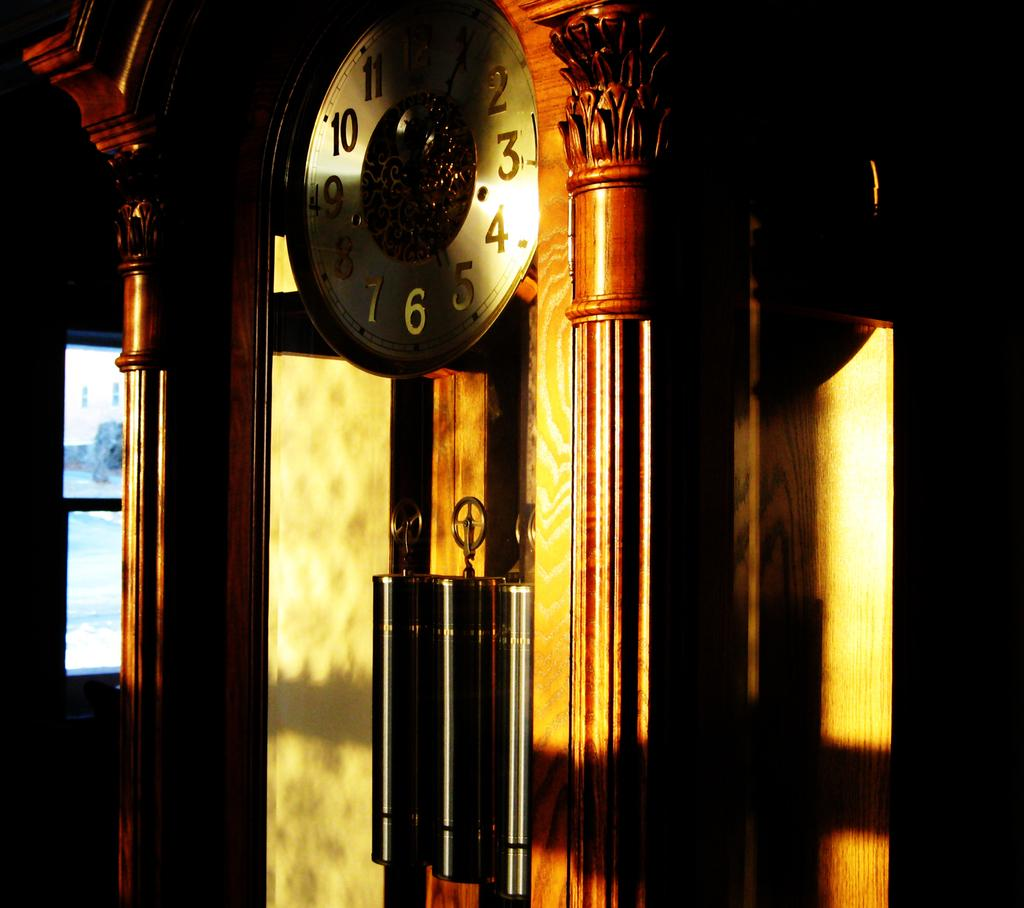<image>
Relay a brief, clear account of the picture shown. A clock with numbers on it in golden sunlight 